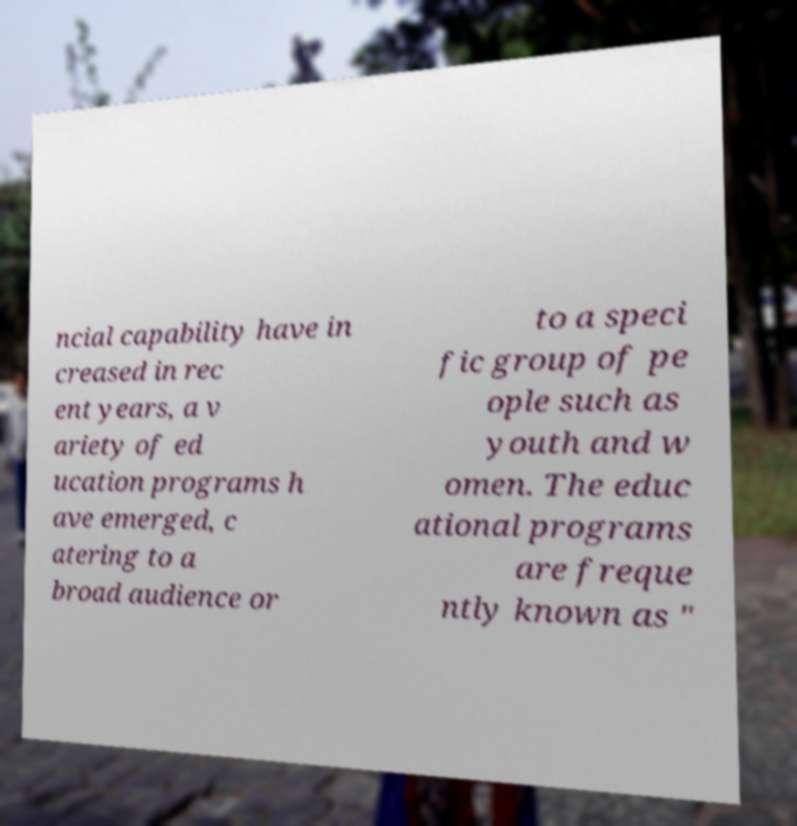Can you accurately transcribe the text from the provided image for me? ncial capability have in creased in rec ent years, a v ariety of ed ucation programs h ave emerged, c atering to a broad audience or to a speci fic group of pe ople such as youth and w omen. The educ ational programs are freque ntly known as " 